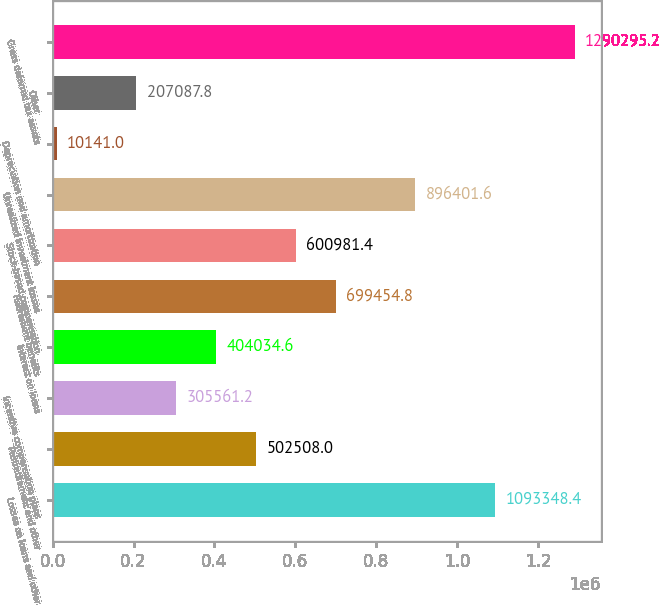Convert chart to OTSL. <chart><loc_0><loc_0><loc_500><loc_500><bar_chart><fcel>Losses on loans and other<fcel>Postretirement and other<fcel>Incentive compensation plans<fcel>Interest on loans<fcel>Retirement benefits<fcel>Stock-based compensation<fcel>Unrealized investment losses<fcel>Depreciation and amortization<fcel>Other<fcel>Gross deferred tax assets<nl><fcel>1.09335e+06<fcel>502508<fcel>305561<fcel>404035<fcel>699455<fcel>600981<fcel>896402<fcel>10141<fcel>207088<fcel>1.2903e+06<nl></chart> 